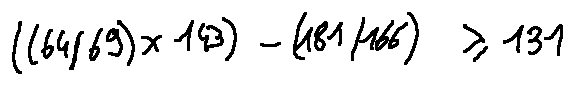Convert formula to latex. <formula><loc_0><loc_0><loc_500><loc_500>( ( 6 4 / 6 9 ) \times 1 4 3 ) - ( 1 8 1 / 1 6 6 ) \geq 1 3 1</formula> 